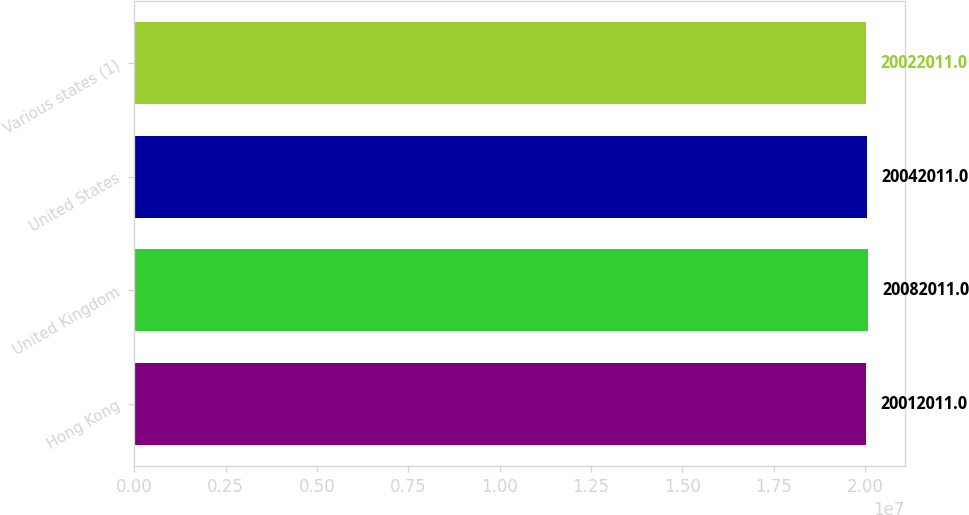Convert chart to OTSL. <chart><loc_0><loc_0><loc_500><loc_500><bar_chart><fcel>Hong Kong<fcel>United Kingdom<fcel>United States<fcel>Various states (1)<nl><fcel>2.0012e+07<fcel>2.0082e+07<fcel>2.0042e+07<fcel>2.0022e+07<nl></chart> 